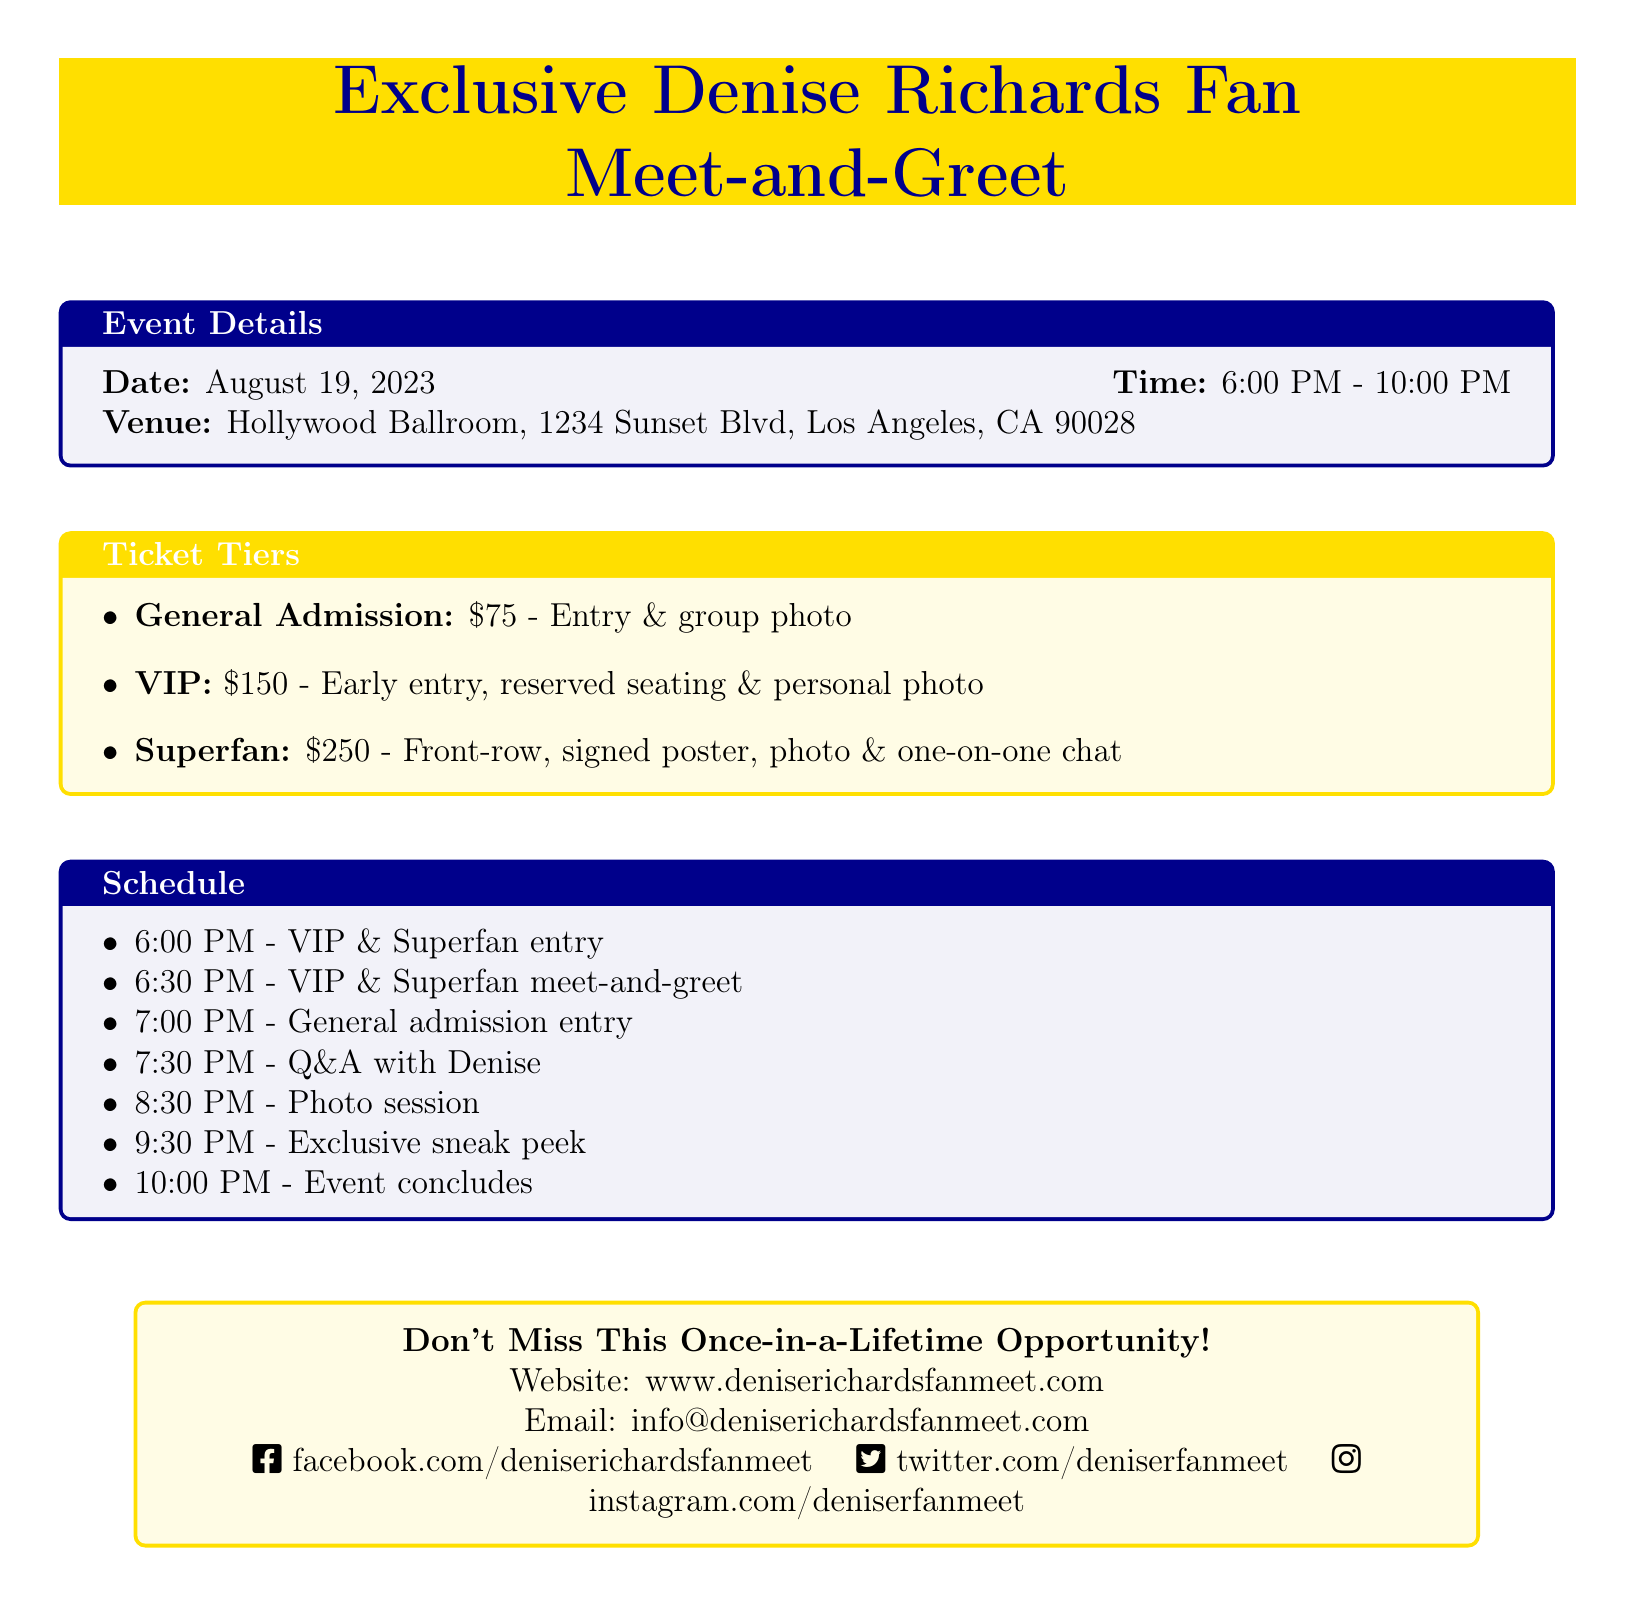What date is the event? The date of the event is specified in the document under Event Details.
Answer: August 19, 2023 What time does the event start? The starting time for the event is given in the Event Details section.
Answer: 6:00 PM Where is the event taking place? The venue for the event is mentioned in the Event Details section of the document.
Answer: Hollywood Ballroom, 1234 Sunset Blvd, Los Angeles, CA 90028 How much is the VIP ticket? The price for the VIP ticket is found in the Ticket Tiers section of the document.
Answer: $150 What activity starts at 8:30 PM? The scheduled activity at 8:30 PM can be found in the Schedule section of the document.
Answer: Photo session What is included in the Superfan ticket? The contents of the Superfan ticket are listed in the Ticket Tiers section and require combining specific details.
Answer: Front-row, signed poster, photo & one-on-one chat What activity occurs right after VIP entry? The follow-up activity to VIP entry is noted in the Schedule section of the document.
Answer: VIP & Superfan meet-and-greet What is the website for more information? The website for additional details is provided at the end of the document.
Answer: www.deniserichardsfanmeet.com 